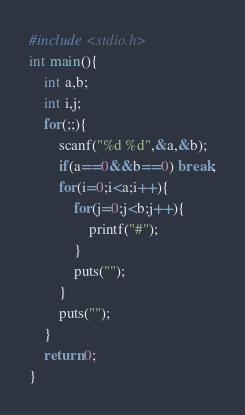<code> <loc_0><loc_0><loc_500><loc_500><_C_>#include <stdio.h>
int main(){
	int a,b;
	int i,j;
	for(;;){
		scanf("%d %d",&a,&b);
		if(a==0&&b==0) break;
		for(i=0;i<a;i++){
			for(j=0;j<b;j++){
				printf("#");
			}
			puts("");
		}
		puts("");
	}
	return 0;
}

</code> 